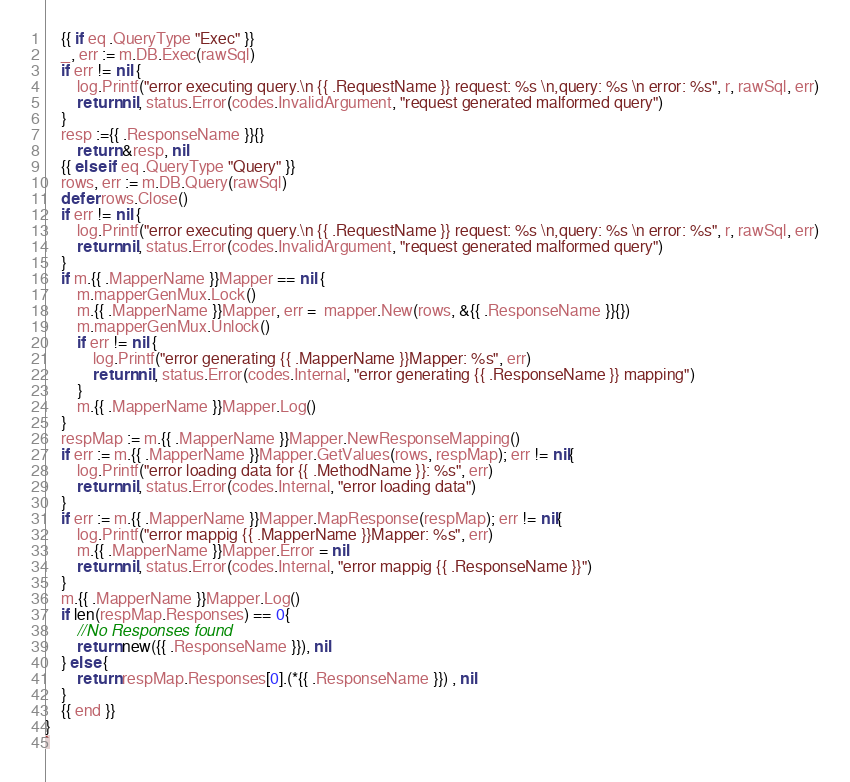<code> <loc_0><loc_0><loc_500><loc_500><_Go_>	{{ if eq .QueryType "Exec" }}
	_, err := m.DB.Exec(rawSql)
	if err != nil {
		log.Printf("error executing query.\n {{ .RequestName }} request: %s \n,query: %s \n error: %s", r, rawSql, err)
		return nil, status.Error(codes.InvalidArgument, "request generated malformed query")
	}
	resp :={{ .ResponseName }}{}
        return &resp, nil
	{{ else if eq .QueryType "Query" }}
	rows, err := m.DB.Query(rawSql)
	defer rows.Close()
	if err != nil {
		log.Printf("error executing query.\n {{ .RequestName }} request: %s \n,query: %s \n error: %s", r, rawSql, err)
		return nil, status.Error(codes.InvalidArgument, "request generated malformed query")
	}
	if m.{{ .MapperName }}Mapper == nil {
		m.mapperGenMux.Lock()
		m.{{ .MapperName }}Mapper, err =  mapper.New(rows, &{{ .ResponseName }}{})
		m.mapperGenMux.Unlock()
		if err != nil {
			log.Printf("error generating {{ .MapperName }}Mapper: %s", err)
			return nil, status.Error(codes.Internal, "error generating {{ .ResponseName }} mapping")
		}
		m.{{ .MapperName }}Mapper.Log()
	}
	respMap := m.{{ .MapperName }}Mapper.NewResponseMapping()
	if err := m.{{ .MapperName }}Mapper.GetValues(rows, respMap); err != nil{
		log.Printf("error loading data for {{ .MethodName }}: %s", err)
		return nil, status.Error(codes.Internal, "error loading data")
	}
	if err := m.{{ .MapperName }}Mapper.MapResponse(respMap); err != nil{
		log.Printf("error mappig {{ .MapperName }}Mapper: %s", err)
		m.{{ .MapperName }}Mapper.Error = nil
		return nil, status.Error(codes.Internal, "error mappig {{ .ResponseName }}")
	}
	m.{{ .MapperName }}Mapper.Log()
	if len(respMap.Responses) == 0{
		//No Responses found
		return new({{ .ResponseName }}), nil
	} else {
		return respMap.Responses[0].(*{{ .ResponseName }}) , nil
	}
	{{ end }}
}
`
</code> 